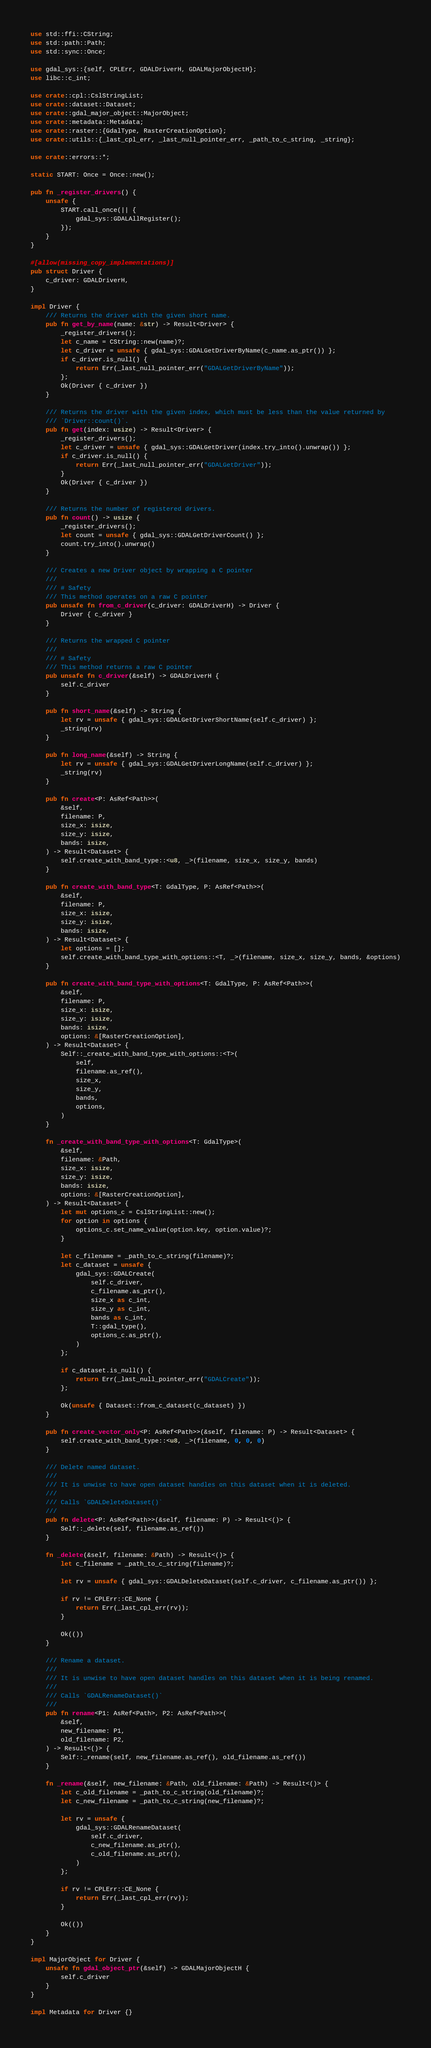<code> <loc_0><loc_0><loc_500><loc_500><_Rust_>use std::ffi::CString;
use std::path::Path;
use std::sync::Once;

use gdal_sys::{self, CPLErr, GDALDriverH, GDALMajorObjectH};
use libc::c_int;

use crate::cpl::CslStringList;
use crate::dataset::Dataset;
use crate::gdal_major_object::MajorObject;
use crate::metadata::Metadata;
use crate::raster::{GdalType, RasterCreationOption};
use crate::utils::{_last_cpl_err, _last_null_pointer_err, _path_to_c_string, _string};

use crate::errors::*;

static START: Once = Once::new();

pub fn _register_drivers() {
    unsafe {
        START.call_once(|| {
            gdal_sys::GDALAllRegister();
        });
    }
}

#[allow(missing_copy_implementations)]
pub struct Driver {
    c_driver: GDALDriverH,
}

impl Driver {
    /// Returns the driver with the given short name.
    pub fn get_by_name(name: &str) -> Result<Driver> {
        _register_drivers();
        let c_name = CString::new(name)?;
        let c_driver = unsafe { gdal_sys::GDALGetDriverByName(c_name.as_ptr()) };
        if c_driver.is_null() {
            return Err(_last_null_pointer_err("GDALGetDriverByName"));
        };
        Ok(Driver { c_driver })
    }

    /// Returns the driver with the given index, which must be less than the value returned by
    /// `Driver::count()`.
    pub fn get(index: usize) -> Result<Driver> {
        _register_drivers();
        let c_driver = unsafe { gdal_sys::GDALGetDriver(index.try_into().unwrap()) };
        if c_driver.is_null() {
            return Err(_last_null_pointer_err("GDALGetDriver"));
        }
        Ok(Driver { c_driver })
    }

    /// Returns the number of registered drivers.
    pub fn count() -> usize {
        _register_drivers();
        let count = unsafe { gdal_sys::GDALGetDriverCount() };
        count.try_into().unwrap()
    }

    /// Creates a new Driver object by wrapping a C pointer
    ///
    /// # Safety
    /// This method operates on a raw C pointer
    pub unsafe fn from_c_driver(c_driver: GDALDriverH) -> Driver {
        Driver { c_driver }
    }

    /// Returns the wrapped C pointer
    ///
    /// # Safety
    /// This method returns a raw C pointer
    pub unsafe fn c_driver(&self) -> GDALDriverH {
        self.c_driver
    }

    pub fn short_name(&self) -> String {
        let rv = unsafe { gdal_sys::GDALGetDriverShortName(self.c_driver) };
        _string(rv)
    }

    pub fn long_name(&self) -> String {
        let rv = unsafe { gdal_sys::GDALGetDriverLongName(self.c_driver) };
        _string(rv)
    }

    pub fn create<P: AsRef<Path>>(
        &self,
        filename: P,
        size_x: isize,
        size_y: isize,
        bands: isize,
    ) -> Result<Dataset> {
        self.create_with_band_type::<u8, _>(filename, size_x, size_y, bands)
    }

    pub fn create_with_band_type<T: GdalType, P: AsRef<Path>>(
        &self,
        filename: P,
        size_x: isize,
        size_y: isize,
        bands: isize,
    ) -> Result<Dataset> {
        let options = [];
        self.create_with_band_type_with_options::<T, _>(filename, size_x, size_y, bands, &options)
    }

    pub fn create_with_band_type_with_options<T: GdalType, P: AsRef<Path>>(
        &self,
        filename: P,
        size_x: isize,
        size_y: isize,
        bands: isize,
        options: &[RasterCreationOption],
    ) -> Result<Dataset> {
        Self::_create_with_band_type_with_options::<T>(
            self,
            filename.as_ref(),
            size_x,
            size_y,
            bands,
            options,
        )
    }

    fn _create_with_band_type_with_options<T: GdalType>(
        &self,
        filename: &Path,
        size_x: isize,
        size_y: isize,
        bands: isize,
        options: &[RasterCreationOption],
    ) -> Result<Dataset> {
        let mut options_c = CslStringList::new();
        for option in options {
            options_c.set_name_value(option.key, option.value)?;
        }

        let c_filename = _path_to_c_string(filename)?;
        let c_dataset = unsafe {
            gdal_sys::GDALCreate(
                self.c_driver,
                c_filename.as_ptr(),
                size_x as c_int,
                size_y as c_int,
                bands as c_int,
                T::gdal_type(),
                options_c.as_ptr(),
            )
        };

        if c_dataset.is_null() {
            return Err(_last_null_pointer_err("GDALCreate"));
        };

        Ok(unsafe { Dataset::from_c_dataset(c_dataset) })
    }

    pub fn create_vector_only<P: AsRef<Path>>(&self, filename: P) -> Result<Dataset> {
        self.create_with_band_type::<u8, _>(filename, 0, 0, 0)
    }

    /// Delete named dataset.
    ///
    /// It is unwise to have open dataset handles on this dataset when it is deleted.
    ///
    /// Calls `GDALDeleteDataset()`
    ///
    pub fn delete<P: AsRef<Path>>(&self, filename: P) -> Result<()> {
        Self::_delete(self, filename.as_ref())
    }

    fn _delete(&self, filename: &Path) -> Result<()> {
        let c_filename = _path_to_c_string(filename)?;

        let rv = unsafe { gdal_sys::GDALDeleteDataset(self.c_driver, c_filename.as_ptr()) };

        if rv != CPLErr::CE_None {
            return Err(_last_cpl_err(rv));
        }

        Ok(())
    }

    /// Rename a dataset.
    ///
    /// It is unwise to have open dataset handles on this dataset when it is being renamed.
    ///
    /// Calls `GDALRenameDataset()`
    ///
    pub fn rename<P1: AsRef<Path>, P2: AsRef<Path>>(
        &self,
        new_filename: P1,
        old_filename: P2,
    ) -> Result<()> {
        Self::_rename(self, new_filename.as_ref(), old_filename.as_ref())
    }

    fn _rename(&self, new_filename: &Path, old_filename: &Path) -> Result<()> {
        let c_old_filename = _path_to_c_string(old_filename)?;
        let c_new_filename = _path_to_c_string(new_filename)?;

        let rv = unsafe {
            gdal_sys::GDALRenameDataset(
                self.c_driver,
                c_new_filename.as_ptr(),
                c_old_filename.as_ptr(),
            )
        };

        if rv != CPLErr::CE_None {
            return Err(_last_cpl_err(rv));
        }

        Ok(())
    }
}

impl MajorObject for Driver {
    unsafe fn gdal_object_ptr(&self) -> GDALMajorObjectH {
        self.c_driver
    }
}

impl Metadata for Driver {}
</code> 